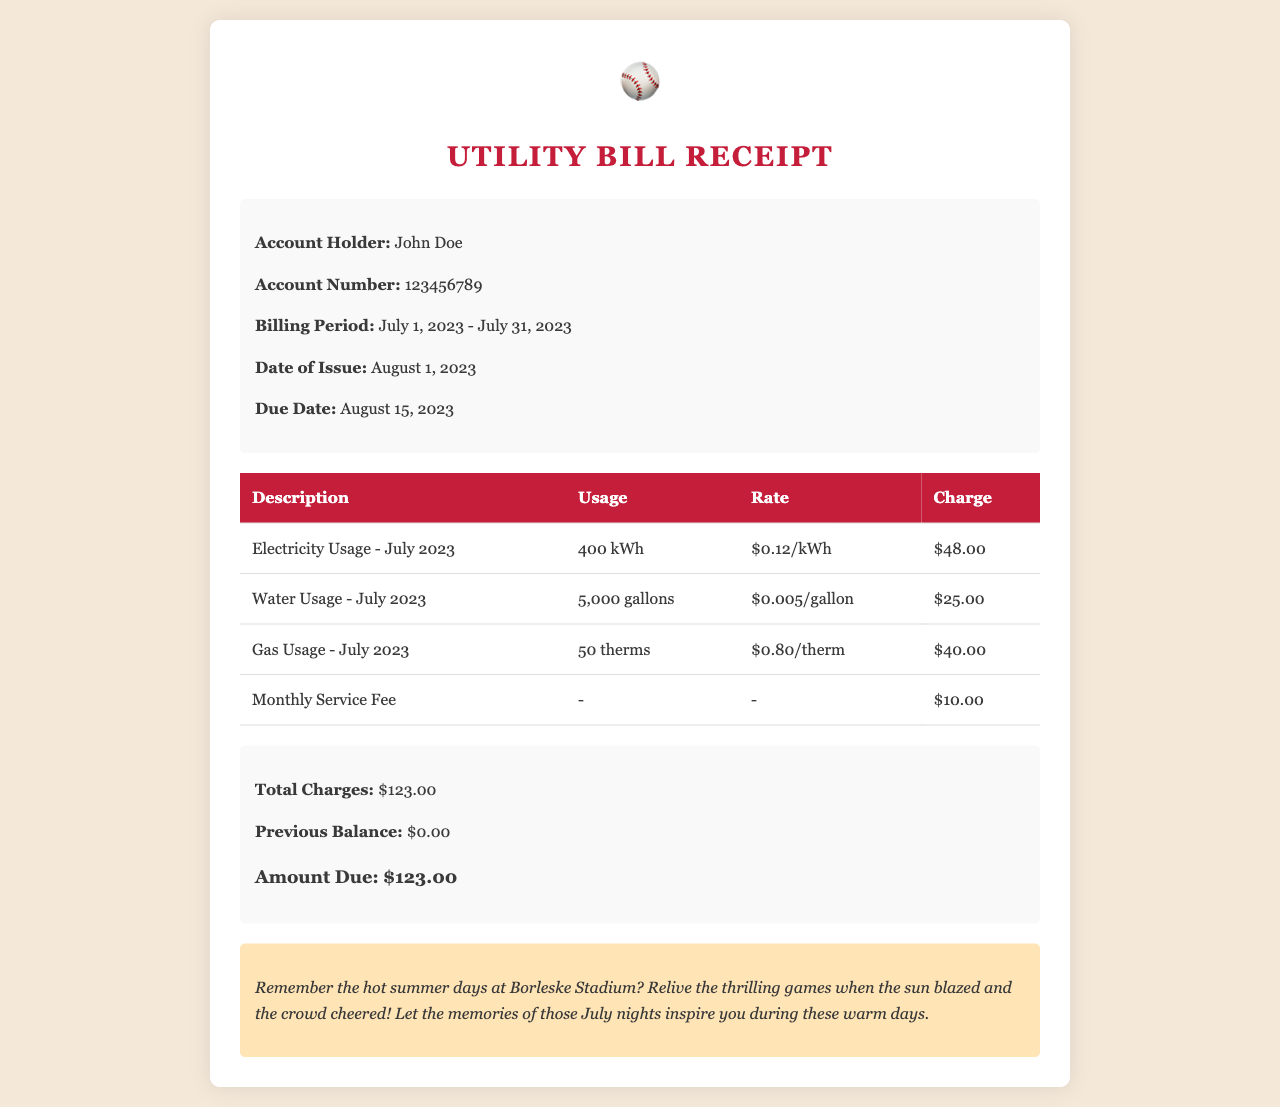What is the account holder's name? The account holder's name is stated at the top of the document.
Answer: John Doe What is the billing period covered in this receipt? The billing period is specified in the header section of the document.
Answer: July 1, 2023 - July 31, 2023 What is the amount due for this utility bill? The amount due is highlighted in the summary section of the document.
Answer: $123.00 How much was charged for electricity usage? The charge for electricity usage is detailed in the charges table.
Answer: $48.00 What is the due date for this utility bill payment? The due date is listed in the header of the document.
Answer: August 15, 2023 How many gallons of water were used in July? The water usage is stated in the charges breakdown.
Answer: 5,000 gallons What was the monthly service fee? The monthly service fee is mentioned in the charges table.
Answer: $10.00 Which sport is referenced in the memo section? The memo section mentions a specific sport related to the nostalgia theme.
Answer: Baseball What type of document is presented here? The overall context of the document deals with utility expenses.
Answer: Utility Bill Receipt 